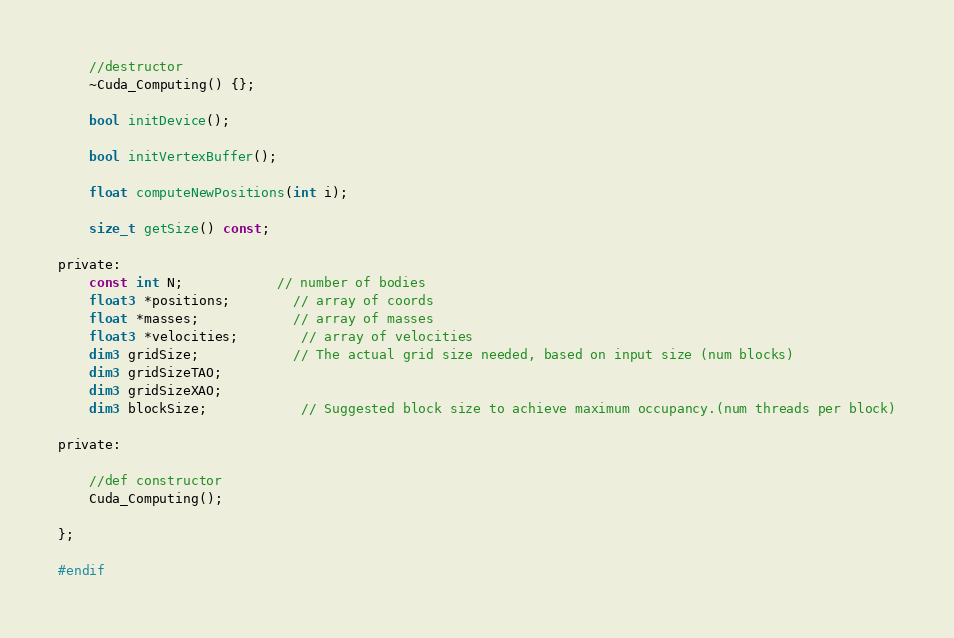<code> <loc_0><loc_0><loc_500><loc_500><_Cuda_>	//destructor
	~Cuda_Computing() {};

	bool initDevice();

	bool initVertexBuffer();

	float computeNewPositions(int i);

	size_t getSize() const;

private:
	const int N;			// number of bodies
	float3 *positions;		// array of coords
	float *masses;			// array of masses
	float3 *velocities;		// array of velocities
	dim3 gridSize;			// The actual grid size needed, based on input size (num blocks)
	dim3 gridSizeTAO;
	dim3 gridSizeXAO;
	dim3 blockSize;			// Suggested block size to achieve maximum occupancy.(num threads per block)

private:

	//def constructor
	Cuda_Computing();

};

#endif</code> 